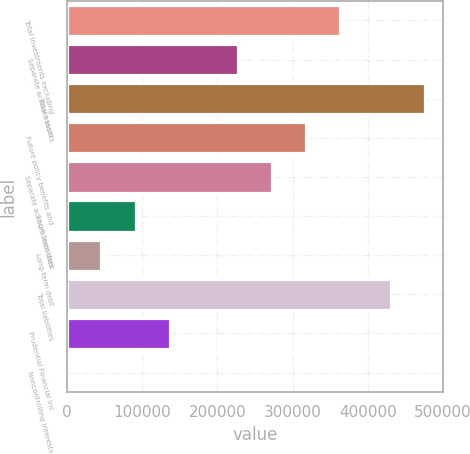Convert chart to OTSL. <chart><loc_0><loc_0><loc_500><loc_500><bar_chart><fcel>Total investments excluding<fcel>Separate account assets<fcel>Total assets<fcel>Future policy benefits and<fcel>Separate account liabilities<fcel>Short-term debt<fcel>Long-term debt<fcel>Total liabilities<fcel>Prudential Financial Inc<fcel>Noncontrolling interests<nl><fcel>363479<fcel>227298<fcel>476399<fcel>318085<fcel>272691<fcel>91116.4<fcel>45722.7<fcel>431005<fcel>136510<fcel>329<nl></chart> 